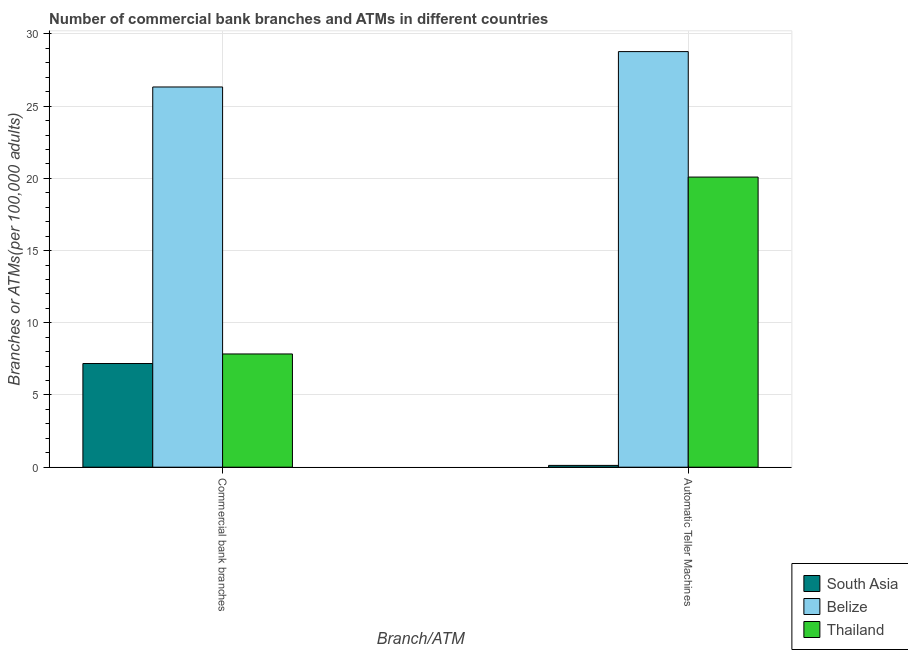Are the number of bars on each tick of the X-axis equal?
Keep it short and to the point. Yes. What is the label of the 2nd group of bars from the left?
Offer a very short reply. Automatic Teller Machines. What is the number of atms in Belize?
Give a very brief answer. 28.78. Across all countries, what is the maximum number of commercal bank branches?
Provide a short and direct response. 26.33. Across all countries, what is the minimum number of atms?
Offer a terse response. 0.12. In which country was the number of atms maximum?
Provide a short and direct response. Belize. In which country was the number of atms minimum?
Make the answer very short. South Asia. What is the total number of atms in the graph?
Provide a short and direct response. 48.99. What is the difference between the number of atms in Belize and that in South Asia?
Your response must be concise. 28.65. What is the difference between the number of commercal bank branches in Thailand and the number of atms in South Asia?
Your answer should be very brief. 7.72. What is the average number of commercal bank branches per country?
Your answer should be compact. 13.78. What is the difference between the number of atms and number of commercal bank branches in South Asia?
Provide a short and direct response. -7.05. In how many countries, is the number of atms greater than 29 ?
Provide a short and direct response. 0. What is the ratio of the number of commercal bank branches in Belize to that in Thailand?
Offer a terse response. 3.36. Is the number of atms in Thailand less than that in South Asia?
Offer a very short reply. No. In how many countries, is the number of atms greater than the average number of atms taken over all countries?
Keep it short and to the point. 2. What does the 1st bar from the left in Commercial bank branches represents?
Your answer should be compact. South Asia. What does the 1st bar from the right in Commercial bank branches represents?
Your response must be concise. Thailand. How many bars are there?
Your response must be concise. 6. What is the difference between two consecutive major ticks on the Y-axis?
Your answer should be very brief. 5. Does the graph contain any zero values?
Offer a terse response. No. Where does the legend appear in the graph?
Ensure brevity in your answer.  Bottom right. How many legend labels are there?
Give a very brief answer. 3. What is the title of the graph?
Offer a terse response. Number of commercial bank branches and ATMs in different countries. Does "Grenada" appear as one of the legend labels in the graph?
Keep it short and to the point. No. What is the label or title of the X-axis?
Your answer should be very brief. Branch/ATM. What is the label or title of the Y-axis?
Offer a very short reply. Branches or ATMs(per 100,0 adults). What is the Branches or ATMs(per 100,000 adults) in South Asia in Commercial bank branches?
Offer a very short reply. 7.18. What is the Branches or ATMs(per 100,000 adults) of Belize in Commercial bank branches?
Provide a succinct answer. 26.33. What is the Branches or ATMs(per 100,000 adults) of Thailand in Commercial bank branches?
Give a very brief answer. 7.84. What is the Branches or ATMs(per 100,000 adults) of South Asia in Automatic Teller Machines?
Provide a succinct answer. 0.12. What is the Branches or ATMs(per 100,000 adults) in Belize in Automatic Teller Machines?
Your answer should be compact. 28.78. What is the Branches or ATMs(per 100,000 adults) of Thailand in Automatic Teller Machines?
Offer a very short reply. 20.09. Across all Branch/ATM, what is the maximum Branches or ATMs(per 100,000 adults) of South Asia?
Offer a terse response. 7.18. Across all Branch/ATM, what is the maximum Branches or ATMs(per 100,000 adults) of Belize?
Keep it short and to the point. 28.78. Across all Branch/ATM, what is the maximum Branches or ATMs(per 100,000 adults) in Thailand?
Keep it short and to the point. 20.09. Across all Branch/ATM, what is the minimum Branches or ATMs(per 100,000 adults) of South Asia?
Provide a short and direct response. 0.12. Across all Branch/ATM, what is the minimum Branches or ATMs(per 100,000 adults) in Belize?
Provide a succinct answer. 26.33. Across all Branch/ATM, what is the minimum Branches or ATMs(per 100,000 adults) of Thailand?
Your response must be concise. 7.84. What is the total Branches or ATMs(per 100,000 adults) of South Asia in the graph?
Give a very brief answer. 7.3. What is the total Branches or ATMs(per 100,000 adults) of Belize in the graph?
Give a very brief answer. 55.11. What is the total Branches or ATMs(per 100,000 adults) in Thailand in the graph?
Your answer should be very brief. 27.93. What is the difference between the Branches or ATMs(per 100,000 adults) of South Asia in Commercial bank branches and that in Automatic Teller Machines?
Offer a very short reply. 7.05. What is the difference between the Branches or ATMs(per 100,000 adults) in Belize in Commercial bank branches and that in Automatic Teller Machines?
Offer a terse response. -2.45. What is the difference between the Branches or ATMs(per 100,000 adults) in Thailand in Commercial bank branches and that in Automatic Teller Machines?
Provide a succinct answer. -12.25. What is the difference between the Branches or ATMs(per 100,000 adults) of South Asia in Commercial bank branches and the Branches or ATMs(per 100,000 adults) of Belize in Automatic Teller Machines?
Offer a terse response. -21.6. What is the difference between the Branches or ATMs(per 100,000 adults) in South Asia in Commercial bank branches and the Branches or ATMs(per 100,000 adults) in Thailand in Automatic Teller Machines?
Your answer should be very brief. -12.91. What is the difference between the Branches or ATMs(per 100,000 adults) in Belize in Commercial bank branches and the Branches or ATMs(per 100,000 adults) in Thailand in Automatic Teller Machines?
Give a very brief answer. 6.24. What is the average Branches or ATMs(per 100,000 adults) of South Asia per Branch/ATM?
Provide a succinct answer. 3.65. What is the average Branches or ATMs(per 100,000 adults) in Belize per Branch/ATM?
Make the answer very short. 27.55. What is the average Branches or ATMs(per 100,000 adults) of Thailand per Branch/ATM?
Your answer should be very brief. 13.97. What is the difference between the Branches or ATMs(per 100,000 adults) in South Asia and Branches or ATMs(per 100,000 adults) in Belize in Commercial bank branches?
Your answer should be very brief. -19.15. What is the difference between the Branches or ATMs(per 100,000 adults) of South Asia and Branches or ATMs(per 100,000 adults) of Thailand in Commercial bank branches?
Your answer should be very brief. -0.66. What is the difference between the Branches or ATMs(per 100,000 adults) of Belize and Branches or ATMs(per 100,000 adults) of Thailand in Commercial bank branches?
Provide a short and direct response. 18.49. What is the difference between the Branches or ATMs(per 100,000 adults) in South Asia and Branches or ATMs(per 100,000 adults) in Belize in Automatic Teller Machines?
Ensure brevity in your answer.  -28.65. What is the difference between the Branches or ATMs(per 100,000 adults) in South Asia and Branches or ATMs(per 100,000 adults) in Thailand in Automatic Teller Machines?
Offer a terse response. -19.96. What is the difference between the Branches or ATMs(per 100,000 adults) of Belize and Branches or ATMs(per 100,000 adults) of Thailand in Automatic Teller Machines?
Your response must be concise. 8.69. What is the ratio of the Branches or ATMs(per 100,000 adults) in South Asia in Commercial bank branches to that in Automatic Teller Machines?
Give a very brief answer. 57.46. What is the ratio of the Branches or ATMs(per 100,000 adults) in Belize in Commercial bank branches to that in Automatic Teller Machines?
Make the answer very short. 0.91. What is the ratio of the Branches or ATMs(per 100,000 adults) in Thailand in Commercial bank branches to that in Automatic Teller Machines?
Provide a succinct answer. 0.39. What is the difference between the highest and the second highest Branches or ATMs(per 100,000 adults) in South Asia?
Provide a succinct answer. 7.05. What is the difference between the highest and the second highest Branches or ATMs(per 100,000 adults) of Belize?
Make the answer very short. 2.45. What is the difference between the highest and the second highest Branches or ATMs(per 100,000 adults) in Thailand?
Offer a very short reply. 12.25. What is the difference between the highest and the lowest Branches or ATMs(per 100,000 adults) of South Asia?
Provide a succinct answer. 7.05. What is the difference between the highest and the lowest Branches or ATMs(per 100,000 adults) in Belize?
Offer a very short reply. 2.45. What is the difference between the highest and the lowest Branches or ATMs(per 100,000 adults) of Thailand?
Offer a terse response. 12.25. 